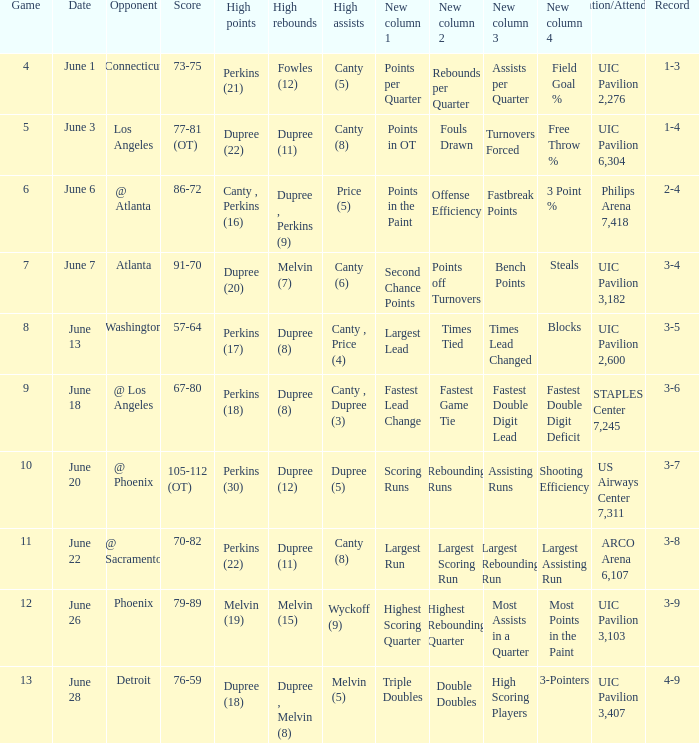What is the date of game 9? June 18. 